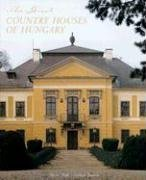Who wrote this book? This exquisite tome credit goes to Michael Pratt, whose expertise in the subject matter shines throughout the book's pages. 